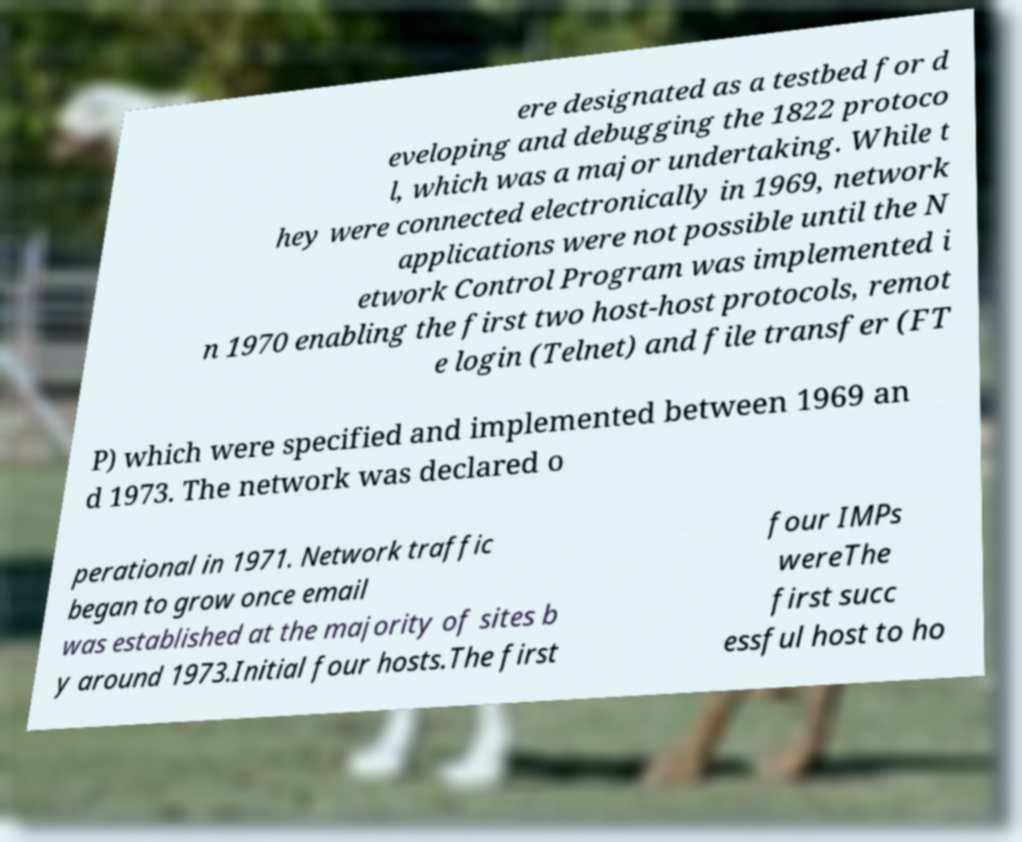Please identify and transcribe the text found in this image. ere designated as a testbed for d eveloping and debugging the 1822 protoco l, which was a major undertaking. While t hey were connected electronically in 1969, network applications were not possible until the N etwork Control Program was implemented i n 1970 enabling the first two host-host protocols, remot e login (Telnet) and file transfer (FT P) which were specified and implemented between 1969 an d 1973. The network was declared o perational in 1971. Network traffic began to grow once email was established at the majority of sites b y around 1973.Initial four hosts.The first four IMPs wereThe first succ essful host to ho 